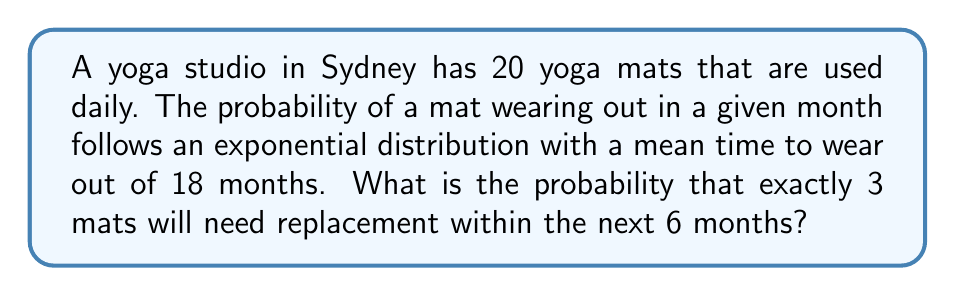Provide a solution to this math problem. Let's approach this step-by-step:

1) First, we need to calculate the rate parameter $\lambda$ for the exponential distribution:
   $\lambda = \frac{1}{\text{mean time}} = \frac{1}{18} \text{ per month}$

2) The probability of a single mat wearing out within 6 months is:
   $p = 1 - e^{-\lambda t} = 1 - e^{-\frac{1}{18} \cdot 6} = 1 - e^{-\frac{1}{3}} \approx 0.2835$

3) This scenario follows a Binomial distribution, where:
   $n = 20$ (total number of mats)
   $k = 3$ (number of mats we want to wear out)
   $p = 0.2835$ (probability of a single mat wearing out)

4) The probability mass function for the Binomial distribution is:
   $$P(X=k) = \binom{n}{k} p^k (1-p)^{n-k}$$

5) Substituting our values:
   $$P(X=3) = \binom{20}{3} (0.2835)^3 (1-0.2835)^{17}$$

6) Calculate:
   $$P(X=3) = 1140 \cdot 0.0228 \cdot 0.0056 \approx 0.1456$$

Thus, the probability of exactly 3 mats needing replacement within 6 months is approximately 0.1456 or 14.56%.
Answer: 0.1456 